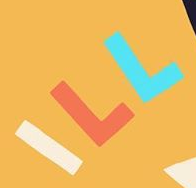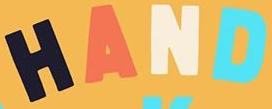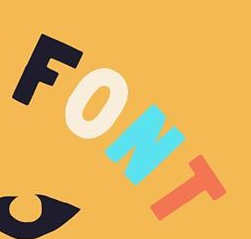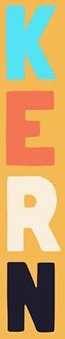What words can you see in these images in sequence, separated by a semicolon? ILL; HAND; FONT; KERN 